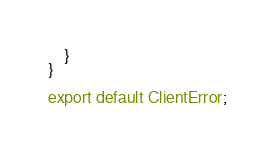<code> <loc_0><loc_0><loc_500><loc_500><_TypeScript_>    }
}

export default ClientError;</code> 